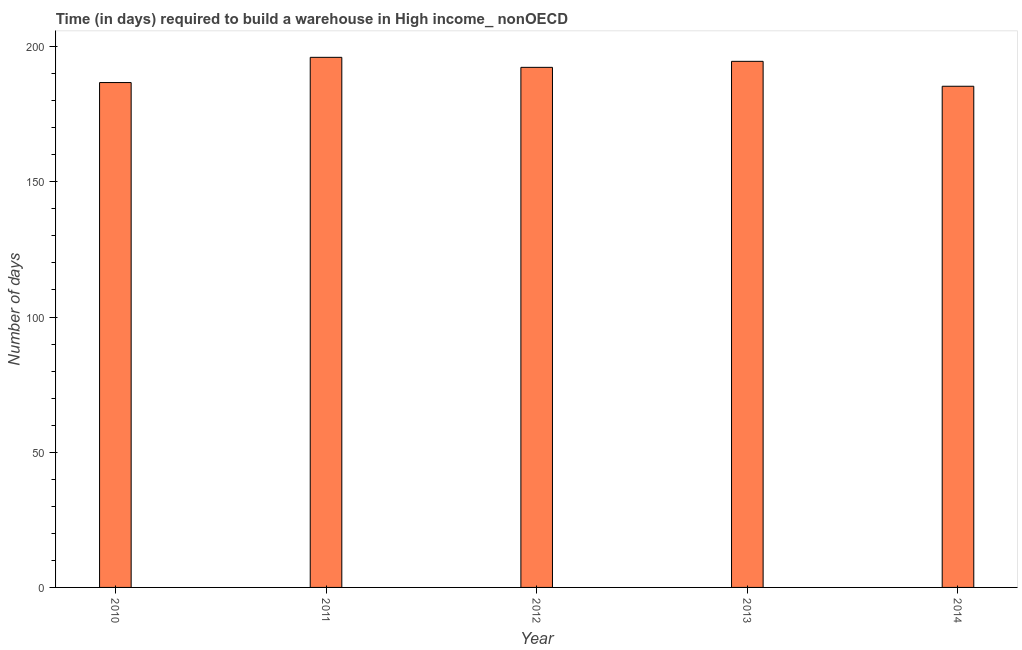What is the title of the graph?
Offer a terse response. Time (in days) required to build a warehouse in High income_ nonOECD. What is the label or title of the Y-axis?
Make the answer very short. Number of days. What is the time required to build a warehouse in 2014?
Give a very brief answer. 185.34. Across all years, what is the maximum time required to build a warehouse?
Your response must be concise. 196.04. Across all years, what is the minimum time required to build a warehouse?
Offer a very short reply. 185.34. In which year was the time required to build a warehouse minimum?
Your answer should be compact. 2014. What is the sum of the time required to build a warehouse?
Offer a terse response. 954.98. What is the difference between the time required to build a warehouse in 2011 and 2013?
Offer a very short reply. 1.48. What is the average time required to build a warehouse per year?
Offer a terse response. 191. What is the median time required to build a warehouse?
Your response must be concise. 192.33. Is the difference between the time required to build a warehouse in 2011 and 2013 greater than the difference between any two years?
Offer a very short reply. No. What is the difference between the highest and the second highest time required to build a warehouse?
Your answer should be very brief. 1.48. How many bars are there?
Your answer should be very brief. 5. Are all the bars in the graph horizontal?
Give a very brief answer. No. What is the difference between two consecutive major ticks on the Y-axis?
Keep it short and to the point. 50. Are the values on the major ticks of Y-axis written in scientific E-notation?
Ensure brevity in your answer.  No. What is the Number of days of 2010?
Your answer should be compact. 186.71. What is the Number of days in 2011?
Your response must be concise. 196.04. What is the Number of days in 2012?
Provide a short and direct response. 192.33. What is the Number of days of 2013?
Offer a very short reply. 194.56. What is the Number of days of 2014?
Offer a very short reply. 185.34. What is the difference between the Number of days in 2010 and 2011?
Your response must be concise. -9.33. What is the difference between the Number of days in 2010 and 2012?
Provide a succinct answer. -5.62. What is the difference between the Number of days in 2010 and 2013?
Provide a succinct answer. -7.85. What is the difference between the Number of days in 2010 and 2014?
Offer a very short reply. 1.37. What is the difference between the Number of days in 2011 and 2012?
Keep it short and to the point. 3.71. What is the difference between the Number of days in 2011 and 2013?
Provide a short and direct response. 1.48. What is the difference between the Number of days in 2011 and 2014?
Your answer should be very brief. 10.7. What is the difference between the Number of days in 2012 and 2013?
Make the answer very short. -2.22. What is the difference between the Number of days in 2012 and 2014?
Ensure brevity in your answer.  6.99. What is the difference between the Number of days in 2013 and 2014?
Your answer should be very brief. 9.22. What is the ratio of the Number of days in 2010 to that in 2011?
Your answer should be compact. 0.95. What is the ratio of the Number of days in 2010 to that in 2012?
Your answer should be very brief. 0.97. What is the ratio of the Number of days in 2010 to that in 2013?
Your response must be concise. 0.96. What is the ratio of the Number of days in 2010 to that in 2014?
Your response must be concise. 1.01. What is the ratio of the Number of days in 2011 to that in 2013?
Provide a succinct answer. 1.01. What is the ratio of the Number of days in 2011 to that in 2014?
Ensure brevity in your answer.  1.06. What is the ratio of the Number of days in 2012 to that in 2013?
Provide a short and direct response. 0.99. What is the ratio of the Number of days in 2012 to that in 2014?
Keep it short and to the point. 1.04. 